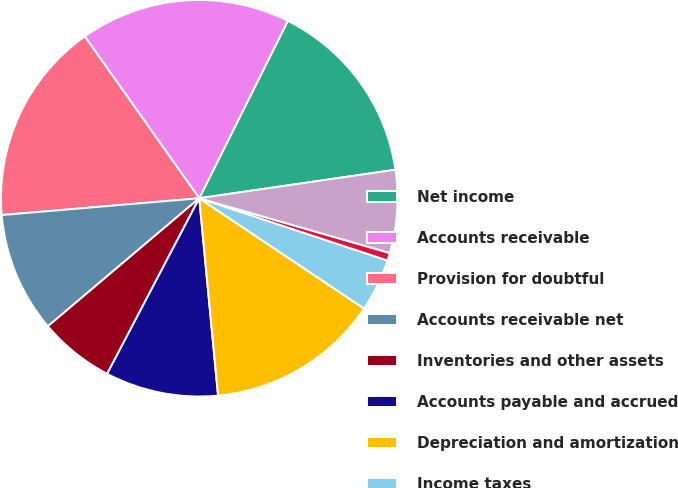Convert chart. <chart><loc_0><loc_0><loc_500><loc_500><pie_chart><fcel>Net income<fcel>Accounts receivable<fcel>Provision for doubtful<fcel>Accounts receivable net<fcel>Inventories and other assets<fcel>Accounts payable and accrued<fcel>Depreciation and amortization<fcel>Income taxes<fcel>Losses (gains) on sales of<fcel>Losses on retirement of debt<nl><fcel>15.33%<fcel>17.17%<fcel>16.55%<fcel>9.82%<fcel>6.14%<fcel>9.2%<fcel>14.1%<fcel>4.3%<fcel>0.63%<fcel>6.75%<nl></chart> 